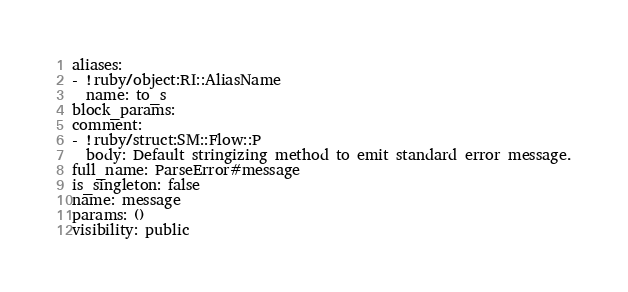Convert code to text. <code><loc_0><loc_0><loc_500><loc_500><_YAML_>aliases: 
- !ruby/object:RI::AliasName 
  name: to_s
block_params: 
comment: 
- !ruby/struct:SM::Flow::P 
  body: Default stringizing method to emit standard error message.
full_name: ParseError#message
is_singleton: false
name: message
params: ()
visibility: public
</code> 